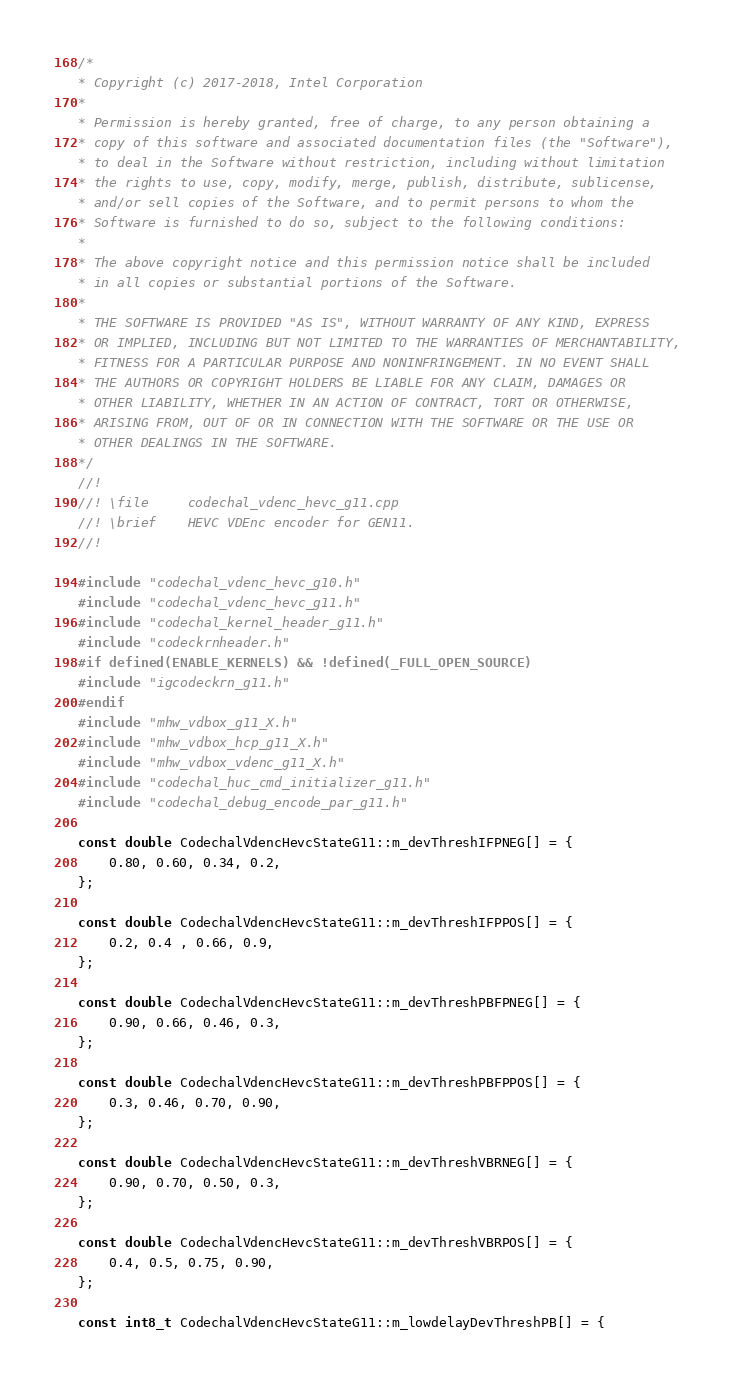<code> <loc_0><loc_0><loc_500><loc_500><_C++_>/*
* Copyright (c) 2017-2018, Intel Corporation
*
* Permission is hereby granted, free of charge, to any person obtaining a
* copy of this software and associated documentation files (the "Software"),
* to deal in the Software without restriction, including without limitation
* the rights to use, copy, modify, merge, publish, distribute, sublicense,
* and/or sell copies of the Software, and to permit persons to whom the
* Software is furnished to do so, subject to the following conditions:
*
* The above copyright notice and this permission notice shall be included
* in all copies or substantial portions of the Software.
*
* THE SOFTWARE IS PROVIDED "AS IS", WITHOUT WARRANTY OF ANY KIND, EXPRESS
* OR IMPLIED, INCLUDING BUT NOT LIMITED TO THE WARRANTIES OF MERCHANTABILITY,
* FITNESS FOR A PARTICULAR PURPOSE AND NONINFRINGEMENT. IN NO EVENT SHALL
* THE AUTHORS OR COPYRIGHT HOLDERS BE LIABLE FOR ANY CLAIM, DAMAGES OR
* OTHER LIABILITY, WHETHER IN AN ACTION OF CONTRACT, TORT OR OTHERWISE,
* ARISING FROM, OUT OF OR IN CONNECTION WITH THE SOFTWARE OR THE USE OR
* OTHER DEALINGS IN THE SOFTWARE.
*/
//!
//! \file     codechal_vdenc_hevc_g11.cpp
//! \brief    HEVC VDEnc encoder for GEN11.
//!

#include "codechal_vdenc_hevc_g10.h"
#include "codechal_vdenc_hevc_g11.h"
#include "codechal_kernel_header_g11.h"
#include "codeckrnheader.h"
#if defined(ENABLE_KERNELS) && !defined(_FULL_OPEN_SOURCE)
#include "igcodeckrn_g11.h"
#endif
#include "mhw_vdbox_g11_X.h"
#include "mhw_vdbox_hcp_g11_X.h"
#include "mhw_vdbox_vdenc_g11_X.h"
#include "codechal_huc_cmd_initializer_g11.h"
#include "codechal_debug_encode_par_g11.h"

const double CodechalVdencHevcStateG11::m_devThreshIFPNEG[] = {
    0.80, 0.60, 0.34, 0.2,
};

const double CodechalVdencHevcStateG11::m_devThreshIFPPOS[] = {
    0.2, 0.4 , 0.66, 0.9,
};

const double CodechalVdencHevcStateG11::m_devThreshPBFPNEG[] = {
    0.90, 0.66, 0.46, 0.3,
};

const double CodechalVdencHevcStateG11::m_devThreshPBFPPOS[] = {
    0.3, 0.46, 0.70, 0.90,
};

const double CodechalVdencHevcStateG11::m_devThreshVBRNEG[] = {
    0.90, 0.70, 0.50, 0.3,
};

const double CodechalVdencHevcStateG11::m_devThreshVBRPOS[] = {
    0.4, 0.5, 0.75, 0.90,
};

const int8_t CodechalVdencHevcStateG11::m_lowdelayDevThreshPB[] = {</code> 